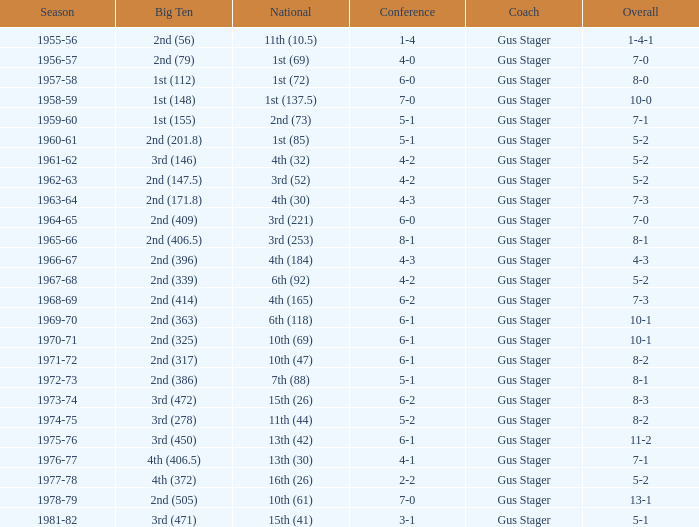What is the Coach with a Big Ten that is 1st (148)? Gus Stager. 